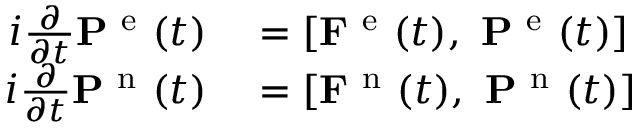<formula> <loc_0><loc_0><loc_500><loc_500>\begin{array} { r l } { i \frac { \partial } { \partial t } P ^ { e } ( t ) } & = \left [ F ^ { e } ( t ) , \ P ^ { e } ( t ) \right ] } \\ { i \frac { \partial } { \partial t } P ^ { n } ( t ) } & = \left [ F ^ { n } ( t ) , \ P ^ { n } ( t ) \right ] } \end{array}</formula> 